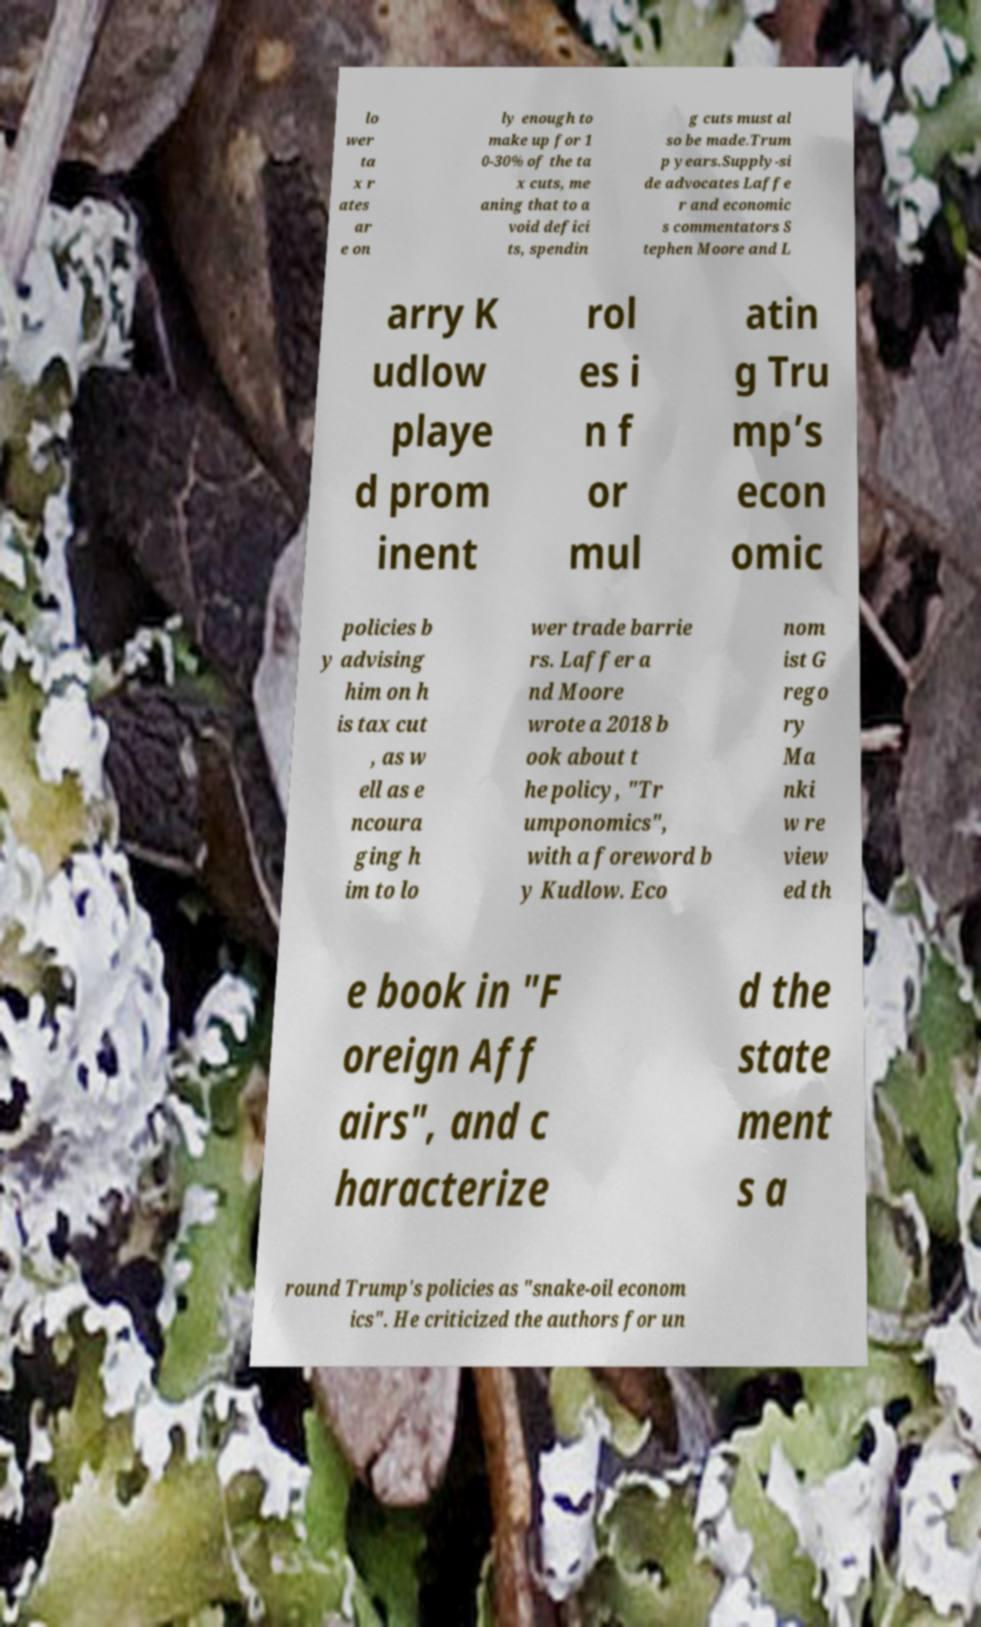Can you accurately transcribe the text from the provided image for me? lo wer ta x r ates ar e on ly enough to make up for 1 0-30% of the ta x cuts, me aning that to a void defici ts, spendin g cuts must al so be made.Trum p years.Supply-si de advocates Laffe r and economic s commentators S tephen Moore and L arry K udlow playe d prom inent rol es i n f or mul atin g Tru mp’s econ omic policies b y advising him on h is tax cut , as w ell as e ncoura ging h im to lo wer trade barrie rs. Laffer a nd Moore wrote a 2018 b ook about t he policy, "Tr umponomics", with a foreword b y Kudlow. Eco nom ist G rego ry Ma nki w re view ed th e book in "F oreign Aff airs", and c haracterize d the state ment s a round Trump's policies as "snake-oil econom ics". He criticized the authors for un 